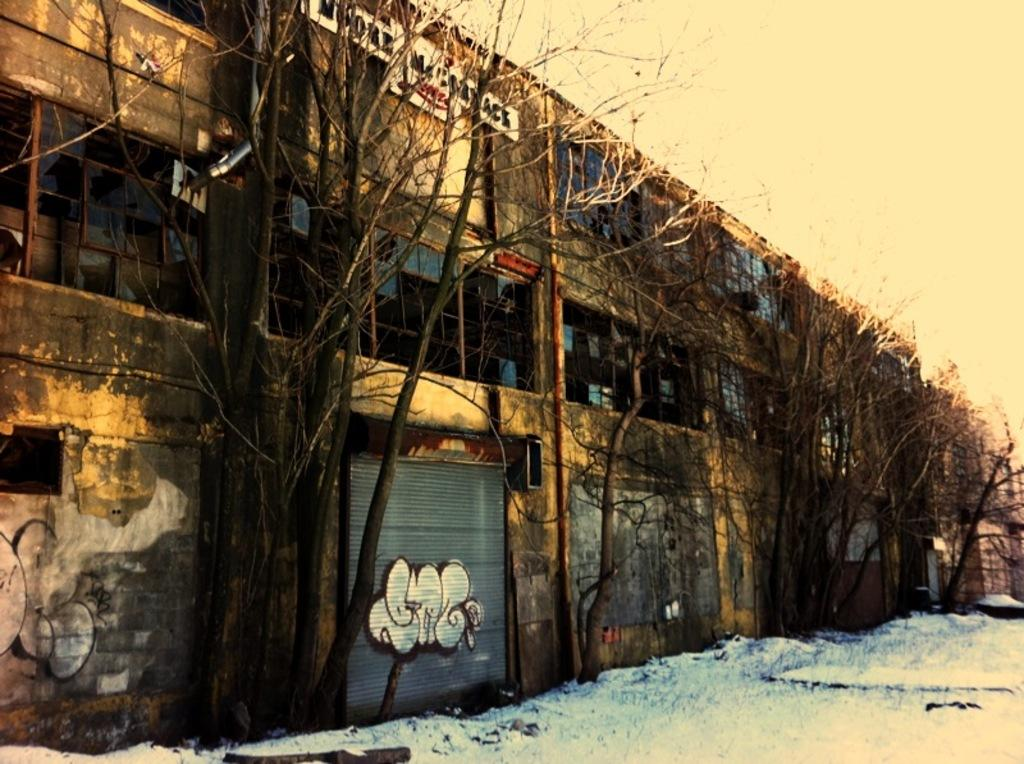What type of structure is present in the image? There is a building in the image. What feature can be seen on the building? The building has a shutter. Where are the windows located on the building? There are windows at the top of the building. What type of vegetation is visible in the image? Trees are visible in the image. What is the ground covered with at the bottom of the image? There is snow at the bottom of the image. What is visible at the top of the image? The sky is visible at the top of the image. What type of car is your dad driving in the image? There is no car or dad present in the image; it features a building with a shutter, windows, trees, snow, and the sky. 